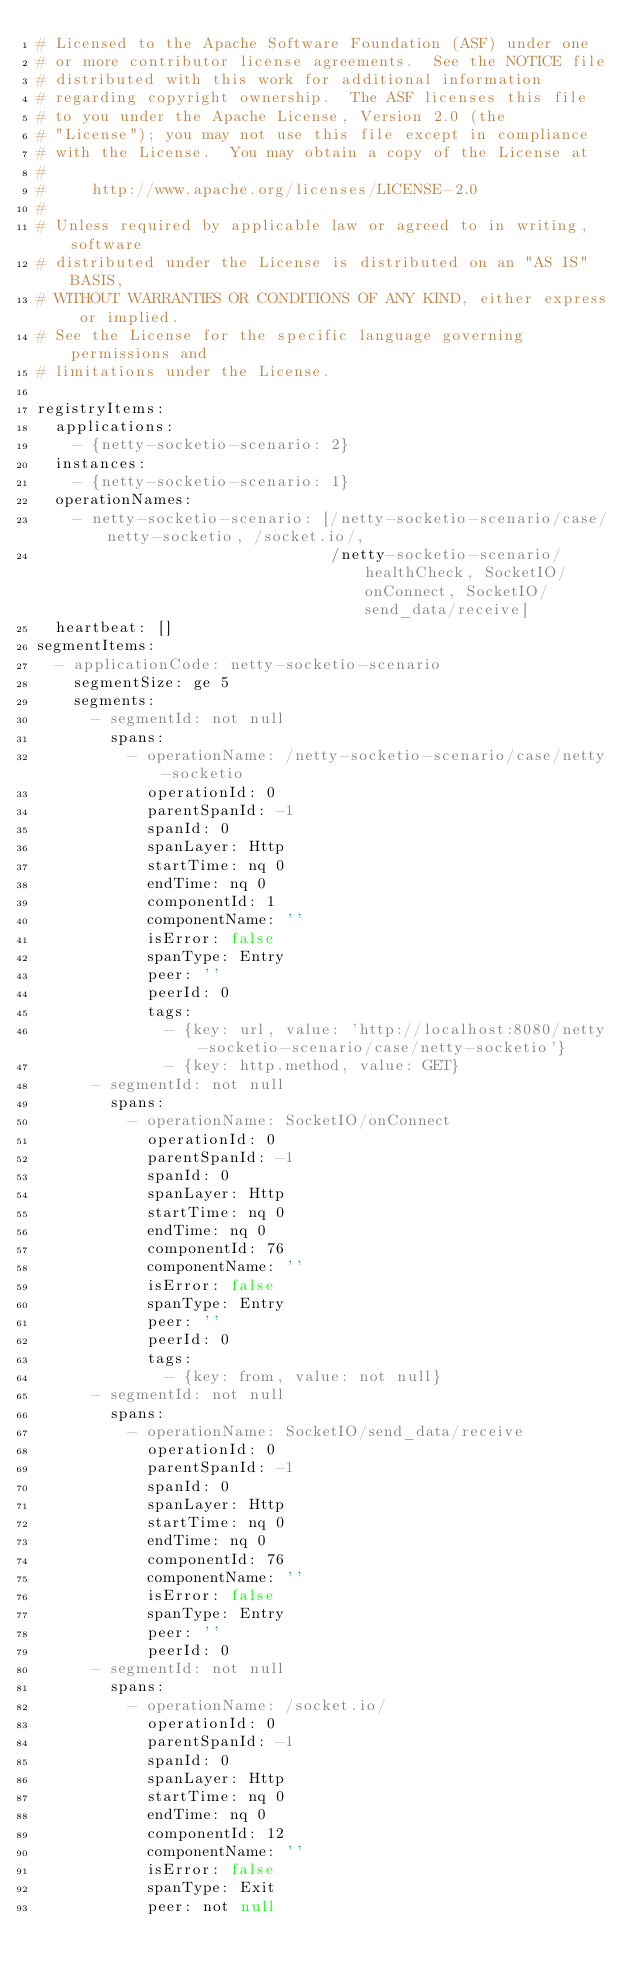Convert code to text. <code><loc_0><loc_0><loc_500><loc_500><_YAML_># Licensed to the Apache Software Foundation (ASF) under one
# or more contributor license agreements.  See the NOTICE file
# distributed with this work for additional information
# regarding copyright ownership.  The ASF licenses this file
# to you under the Apache License, Version 2.0 (the
# "License"); you may not use this file except in compliance
# with the License.  You may obtain a copy of the License at
#
#     http://www.apache.org/licenses/LICENSE-2.0
#
# Unless required by applicable law or agreed to in writing, software
# distributed under the License is distributed on an "AS IS" BASIS,
# WITHOUT WARRANTIES OR CONDITIONS OF ANY KIND, either express or implied.
# See the License for the specific language governing permissions and
# limitations under the License.

registryItems:
  applications:
    - {netty-socketio-scenario: 2}
  instances:
    - {netty-socketio-scenario: 1}
  operationNames:
    - netty-socketio-scenario: [/netty-socketio-scenario/case/netty-socketio, /socket.io/,
                                /netty-socketio-scenario/healthCheck, SocketIO/onConnect, SocketIO/send_data/receive]
  heartbeat: []
segmentItems:
  - applicationCode: netty-socketio-scenario
    segmentSize: ge 5
    segments:
      - segmentId: not null
        spans:
          - operationName: /netty-socketio-scenario/case/netty-socketio
            operationId: 0
            parentSpanId: -1
            spanId: 0
            spanLayer: Http
            startTime: nq 0
            endTime: nq 0
            componentId: 1
            componentName: ''
            isError: false
            spanType: Entry
            peer: ''
            peerId: 0
            tags:
              - {key: url, value: 'http://localhost:8080/netty-socketio-scenario/case/netty-socketio'}
              - {key: http.method, value: GET}
      - segmentId: not null
        spans:
          - operationName: SocketIO/onConnect
            operationId: 0
            parentSpanId: -1
            spanId: 0
            spanLayer: Http
            startTime: nq 0
            endTime: nq 0
            componentId: 76
            componentName: ''
            isError: false
            spanType: Entry
            peer: ''
            peerId: 0
            tags:
              - {key: from, value: not null}
      - segmentId: not null
        spans:
          - operationName: SocketIO/send_data/receive
            operationId: 0
            parentSpanId: -1
            spanId: 0
            spanLayer: Http
            startTime: nq 0
            endTime: nq 0
            componentId: 76
            componentName: ''
            isError: false
            spanType: Entry
            peer: ''
            peerId: 0
      - segmentId: not null
        spans:
          - operationName: /socket.io/
            operationId: 0
            parentSpanId: -1
            spanId: 0
            spanLayer: Http
            startTime: nq 0
            endTime: nq 0
            componentId: 12
            componentName: ''
            isError: false
            spanType: Exit
            peer: not null</code> 